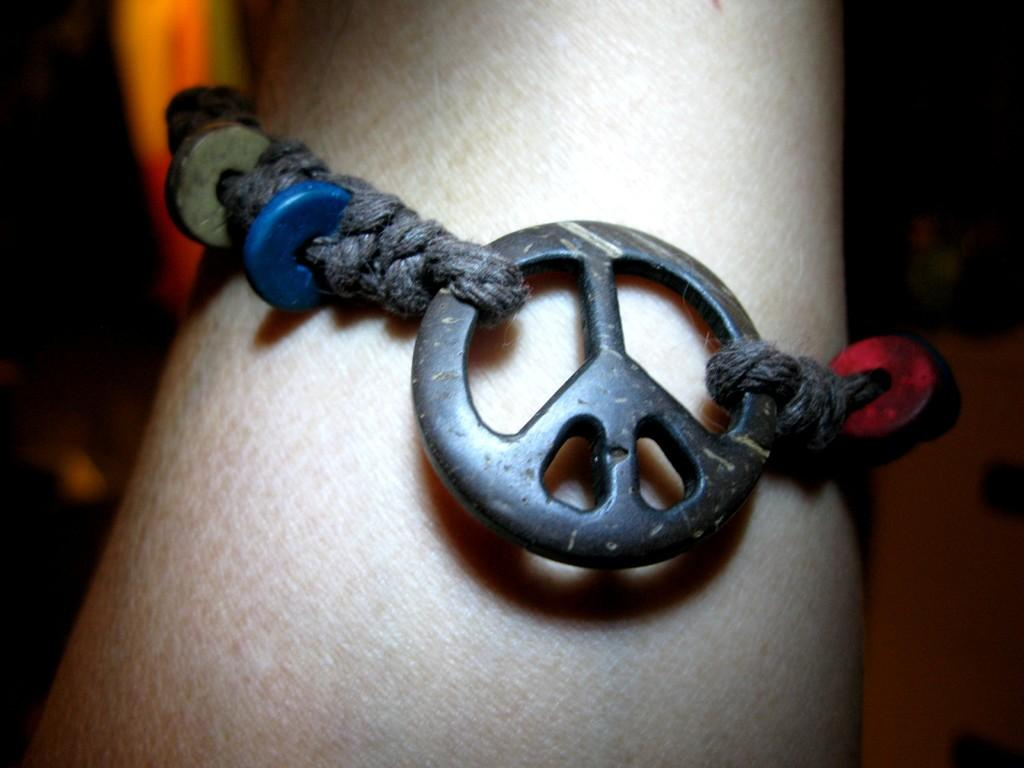What type of accessory is visible on the hand in the image? There is a band bracelet on a hand in the image. Can you describe the background of the image? The background of the image is dark. What type of farm equipment is visible in the image? There is no farm equipment present in the image; it features a band bracelet on a hand with a dark background. How does the band bracelet affect the hearing of the person in the image? The band bracelet does not affect the hearing of the person in the image, as it is an accessory worn on the wrist and not related to hearing. 